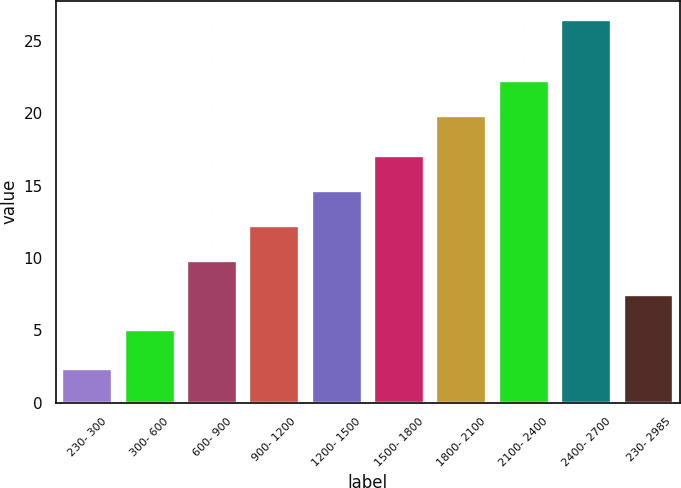Convert chart to OTSL. <chart><loc_0><loc_0><loc_500><loc_500><bar_chart><fcel>230- 300<fcel>300- 600<fcel>600- 900<fcel>900- 1200<fcel>1200- 1500<fcel>1500- 1800<fcel>1800- 2100<fcel>2100- 2400<fcel>2400- 2700<fcel>230- 2985<nl><fcel>2.3<fcel>5<fcel>9.82<fcel>12.23<fcel>14.64<fcel>17.05<fcel>19.78<fcel>22.19<fcel>26.44<fcel>7.41<nl></chart> 